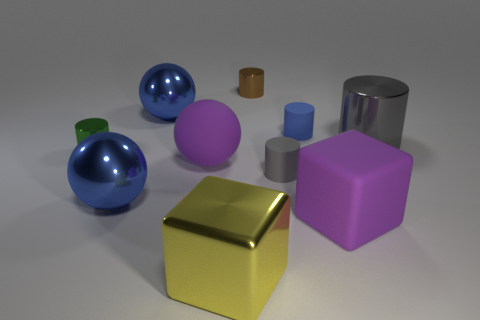Can you describe the lighting and shadows in the scene? The image exhibits soft, diffuse lighting that softly illuminates the objects from above, casting gentle shadows on the ground toward the right of each object, which adds a sense of depth and dimension to the scene. 